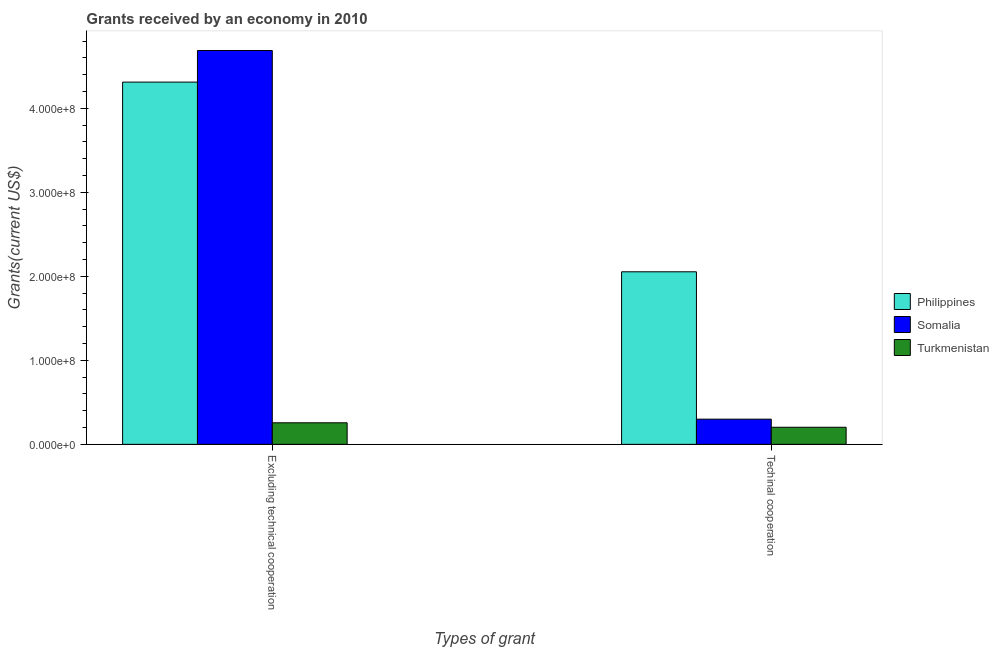How many different coloured bars are there?
Make the answer very short. 3. Are the number of bars per tick equal to the number of legend labels?
Make the answer very short. Yes. How many bars are there on the 1st tick from the right?
Your answer should be compact. 3. What is the label of the 2nd group of bars from the left?
Your response must be concise. Techinal cooperation. What is the amount of grants received(excluding technical cooperation) in Philippines?
Provide a short and direct response. 4.31e+08. Across all countries, what is the maximum amount of grants received(excluding technical cooperation)?
Make the answer very short. 4.69e+08. Across all countries, what is the minimum amount of grants received(excluding technical cooperation)?
Your answer should be compact. 2.57e+07. In which country was the amount of grants received(including technical cooperation) minimum?
Provide a succinct answer. Turkmenistan. What is the total amount of grants received(including technical cooperation) in the graph?
Offer a very short reply. 2.56e+08. What is the difference between the amount of grants received(excluding technical cooperation) in Philippines and that in Turkmenistan?
Your answer should be compact. 4.06e+08. What is the difference between the amount of grants received(including technical cooperation) in Somalia and the amount of grants received(excluding technical cooperation) in Philippines?
Provide a short and direct response. -4.01e+08. What is the average amount of grants received(including technical cooperation) per country?
Offer a very short reply. 8.52e+07. What is the difference between the amount of grants received(including technical cooperation) and amount of grants received(excluding technical cooperation) in Somalia?
Give a very brief answer. -4.39e+08. What is the ratio of the amount of grants received(including technical cooperation) in Philippines to that in Turkmenistan?
Your response must be concise. 10.09. Is the amount of grants received(excluding technical cooperation) in Somalia less than that in Philippines?
Offer a terse response. No. What does the 2nd bar from the left in Excluding technical cooperation represents?
Offer a very short reply. Somalia. What does the 1st bar from the right in Excluding technical cooperation represents?
Your answer should be very brief. Turkmenistan. How many bars are there?
Give a very brief answer. 6. What is the difference between two consecutive major ticks on the Y-axis?
Your answer should be very brief. 1.00e+08. How are the legend labels stacked?
Your response must be concise. Vertical. What is the title of the graph?
Provide a succinct answer. Grants received by an economy in 2010. What is the label or title of the X-axis?
Your answer should be compact. Types of grant. What is the label or title of the Y-axis?
Keep it short and to the point. Grants(current US$). What is the Grants(current US$) in Philippines in Excluding technical cooperation?
Give a very brief answer. 4.31e+08. What is the Grants(current US$) in Somalia in Excluding technical cooperation?
Provide a succinct answer. 4.69e+08. What is the Grants(current US$) of Turkmenistan in Excluding technical cooperation?
Offer a terse response. 2.57e+07. What is the Grants(current US$) in Philippines in Techinal cooperation?
Offer a terse response. 2.05e+08. What is the Grants(current US$) in Somalia in Techinal cooperation?
Make the answer very short. 3.00e+07. What is the Grants(current US$) in Turkmenistan in Techinal cooperation?
Keep it short and to the point. 2.04e+07. Across all Types of grant, what is the maximum Grants(current US$) of Philippines?
Keep it short and to the point. 4.31e+08. Across all Types of grant, what is the maximum Grants(current US$) in Somalia?
Give a very brief answer. 4.69e+08. Across all Types of grant, what is the maximum Grants(current US$) in Turkmenistan?
Provide a succinct answer. 2.57e+07. Across all Types of grant, what is the minimum Grants(current US$) in Philippines?
Your answer should be very brief. 2.05e+08. Across all Types of grant, what is the minimum Grants(current US$) of Somalia?
Ensure brevity in your answer.  3.00e+07. Across all Types of grant, what is the minimum Grants(current US$) of Turkmenistan?
Make the answer very short. 2.04e+07. What is the total Grants(current US$) in Philippines in the graph?
Offer a very short reply. 6.37e+08. What is the total Grants(current US$) in Somalia in the graph?
Ensure brevity in your answer.  4.99e+08. What is the total Grants(current US$) of Turkmenistan in the graph?
Your answer should be compact. 4.60e+07. What is the difference between the Grants(current US$) in Philippines in Excluding technical cooperation and that in Techinal cooperation?
Offer a terse response. 2.26e+08. What is the difference between the Grants(current US$) of Somalia in Excluding technical cooperation and that in Techinal cooperation?
Offer a terse response. 4.39e+08. What is the difference between the Grants(current US$) of Turkmenistan in Excluding technical cooperation and that in Techinal cooperation?
Offer a terse response. 5.32e+06. What is the difference between the Grants(current US$) of Philippines in Excluding technical cooperation and the Grants(current US$) of Somalia in Techinal cooperation?
Offer a very short reply. 4.01e+08. What is the difference between the Grants(current US$) in Philippines in Excluding technical cooperation and the Grants(current US$) in Turkmenistan in Techinal cooperation?
Keep it short and to the point. 4.11e+08. What is the difference between the Grants(current US$) of Somalia in Excluding technical cooperation and the Grants(current US$) of Turkmenistan in Techinal cooperation?
Give a very brief answer. 4.48e+08. What is the average Grants(current US$) of Philippines per Types of grant?
Make the answer very short. 3.18e+08. What is the average Grants(current US$) of Somalia per Types of grant?
Offer a very short reply. 2.49e+08. What is the average Grants(current US$) in Turkmenistan per Types of grant?
Offer a terse response. 2.30e+07. What is the difference between the Grants(current US$) of Philippines and Grants(current US$) of Somalia in Excluding technical cooperation?
Provide a short and direct response. -3.76e+07. What is the difference between the Grants(current US$) of Philippines and Grants(current US$) of Turkmenistan in Excluding technical cooperation?
Give a very brief answer. 4.06e+08. What is the difference between the Grants(current US$) of Somalia and Grants(current US$) of Turkmenistan in Excluding technical cooperation?
Offer a terse response. 4.43e+08. What is the difference between the Grants(current US$) in Philippines and Grants(current US$) in Somalia in Techinal cooperation?
Make the answer very short. 1.75e+08. What is the difference between the Grants(current US$) in Philippines and Grants(current US$) in Turkmenistan in Techinal cooperation?
Your answer should be compact. 1.85e+08. What is the difference between the Grants(current US$) in Somalia and Grants(current US$) in Turkmenistan in Techinal cooperation?
Your response must be concise. 9.63e+06. What is the ratio of the Grants(current US$) of Philippines in Excluding technical cooperation to that in Techinal cooperation?
Provide a short and direct response. 2.1. What is the ratio of the Grants(current US$) of Somalia in Excluding technical cooperation to that in Techinal cooperation?
Ensure brevity in your answer.  15.64. What is the ratio of the Grants(current US$) of Turkmenistan in Excluding technical cooperation to that in Techinal cooperation?
Offer a very short reply. 1.26. What is the difference between the highest and the second highest Grants(current US$) in Philippines?
Give a very brief answer. 2.26e+08. What is the difference between the highest and the second highest Grants(current US$) of Somalia?
Your response must be concise. 4.39e+08. What is the difference between the highest and the second highest Grants(current US$) of Turkmenistan?
Offer a very short reply. 5.32e+06. What is the difference between the highest and the lowest Grants(current US$) of Philippines?
Provide a succinct answer. 2.26e+08. What is the difference between the highest and the lowest Grants(current US$) in Somalia?
Ensure brevity in your answer.  4.39e+08. What is the difference between the highest and the lowest Grants(current US$) in Turkmenistan?
Make the answer very short. 5.32e+06. 